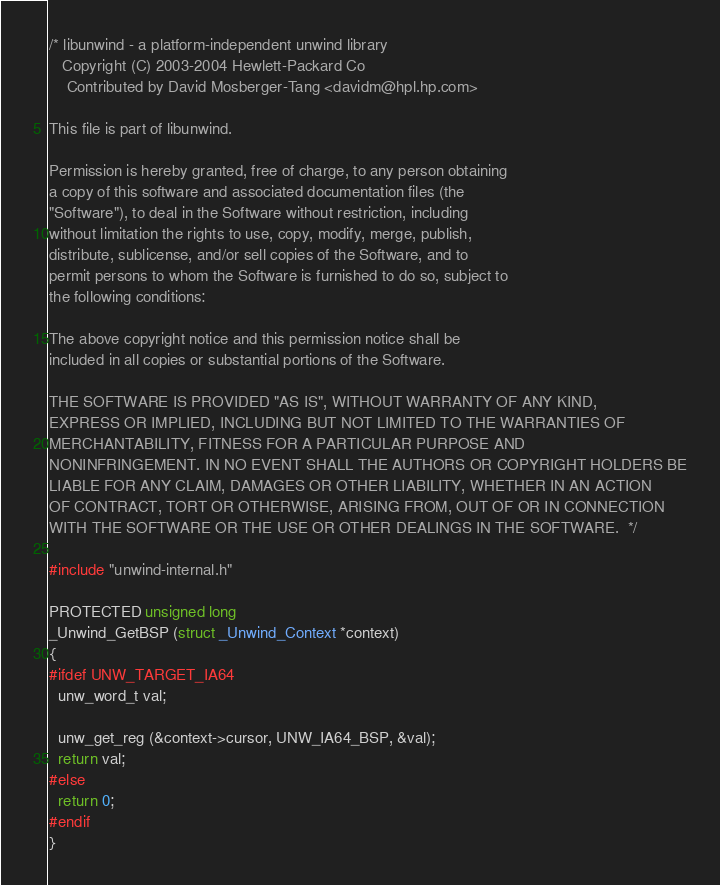Convert code to text. <code><loc_0><loc_0><loc_500><loc_500><_C_>/* libunwind - a platform-independent unwind library
   Copyright (C) 2003-2004 Hewlett-Packard Co
	Contributed by David Mosberger-Tang <davidm@hpl.hp.com>

This file is part of libunwind.

Permission is hereby granted, free of charge, to any person obtaining
a copy of this software and associated documentation files (the
"Software"), to deal in the Software without restriction, including
without limitation the rights to use, copy, modify, merge, publish,
distribute, sublicense, and/or sell copies of the Software, and to
permit persons to whom the Software is furnished to do so, subject to
the following conditions:

The above copyright notice and this permission notice shall be
included in all copies or substantial portions of the Software.

THE SOFTWARE IS PROVIDED "AS IS", WITHOUT WARRANTY OF ANY KIND,
EXPRESS OR IMPLIED, INCLUDING BUT NOT LIMITED TO THE WARRANTIES OF
MERCHANTABILITY, FITNESS FOR A PARTICULAR PURPOSE AND
NONINFRINGEMENT. IN NO EVENT SHALL THE AUTHORS OR COPYRIGHT HOLDERS BE
LIABLE FOR ANY CLAIM, DAMAGES OR OTHER LIABILITY, WHETHER IN AN ACTION
OF CONTRACT, TORT OR OTHERWISE, ARISING FROM, OUT OF OR IN CONNECTION
WITH THE SOFTWARE OR THE USE OR OTHER DEALINGS IN THE SOFTWARE.  */

#include "unwind-internal.h"

PROTECTED unsigned long
_Unwind_GetBSP (struct _Unwind_Context *context)
{
#ifdef UNW_TARGET_IA64
  unw_word_t val;

  unw_get_reg (&context->cursor, UNW_IA64_BSP, &val);
  return val;
#else
  return 0;
#endif
}
</code> 